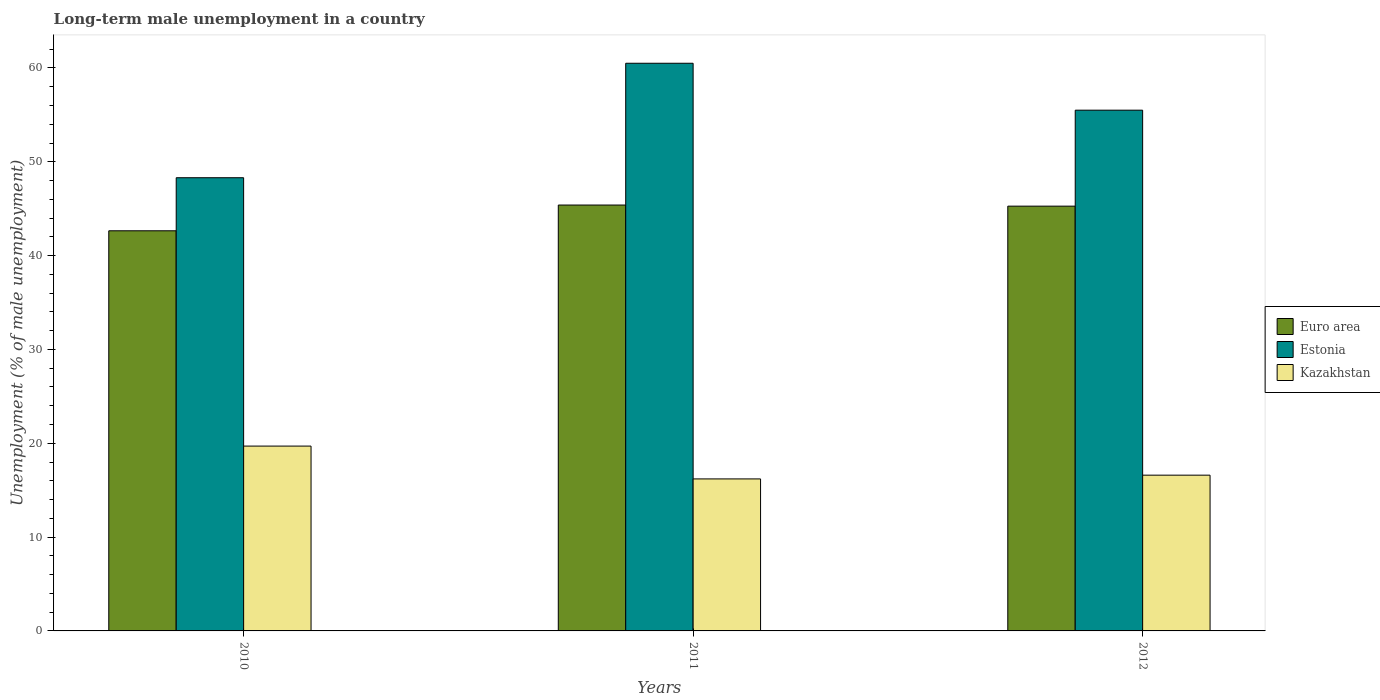How many different coloured bars are there?
Give a very brief answer. 3. Are the number of bars on each tick of the X-axis equal?
Provide a succinct answer. Yes. How many bars are there on the 3rd tick from the left?
Provide a succinct answer. 3. What is the percentage of long-term unemployed male population in Estonia in 2010?
Your response must be concise. 48.3. Across all years, what is the maximum percentage of long-term unemployed male population in Kazakhstan?
Offer a terse response. 19.7. Across all years, what is the minimum percentage of long-term unemployed male population in Euro area?
Your answer should be compact. 42.65. In which year was the percentage of long-term unemployed male population in Kazakhstan maximum?
Your response must be concise. 2010. In which year was the percentage of long-term unemployed male population in Estonia minimum?
Keep it short and to the point. 2010. What is the total percentage of long-term unemployed male population in Kazakhstan in the graph?
Make the answer very short. 52.5. What is the difference between the percentage of long-term unemployed male population in Estonia in 2010 and that in 2011?
Offer a very short reply. -12.2. What is the difference between the percentage of long-term unemployed male population in Estonia in 2010 and the percentage of long-term unemployed male population in Kazakhstan in 2012?
Your answer should be very brief. 31.7. What is the average percentage of long-term unemployed male population in Estonia per year?
Offer a very short reply. 54.77. In the year 2011, what is the difference between the percentage of long-term unemployed male population in Kazakhstan and percentage of long-term unemployed male population in Euro area?
Your answer should be very brief. -29.19. In how many years, is the percentage of long-term unemployed male population in Estonia greater than 16 %?
Give a very brief answer. 3. What is the ratio of the percentage of long-term unemployed male population in Kazakhstan in 2010 to that in 2011?
Ensure brevity in your answer.  1.22. Is the percentage of long-term unemployed male population in Kazakhstan in 2010 less than that in 2011?
Your answer should be very brief. No. What is the difference between the highest and the lowest percentage of long-term unemployed male population in Euro area?
Provide a succinct answer. 2.74. In how many years, is the percentage of long-term unemployed male population in Estonia greater than the average percentage of long-term unemployed male population in Estonia taken over all years?
Keep it short and to the point. 2. What does the 2nd bar from the left in 2010 represents?
Make the answer very short. Estonia. What does the 2nd bar from the right in 2012 represents?
Offer a very short reply. Estonia. How many years are there in the graph?
Provide a short and direct response. 3. What is the difference between two consecutive major ticks on the Y-axis?
Keep it short and to the point. 10. Are the values on the major ticks of Y-axis written in scientific E-notation?
Offer a very short reply. No. How many legend labels are there?
Keep it short and to the point. 3. What is the title of the graph?
Your response must be concise. Long-term male unemployment in a country. Does "Cabo Verde" appear as one of the legend labels in the graph?
Provide a short and direct response. No. What is the label or title of the X-axis?
Provide a succinct answer. Years. What is the label or title of the Y-axis?
Give a very brief answer. Unemployment (% of male unemployment). What is the Unemployment (% of male unemployment) in Euro area in 2010?
Give a very brief answer. 42.65. What is the Unemployment (% of male unemployment) of Estonia in 2010?
Make the answer very short. 48.3. What is the Unemployment (% of male unemployment) of Kazakhstan in 2010?
Keep it short and to the point. 19.7. What is the Unemployment (% of male unemployment) of Euro area in 2011?
Your response must be concise. 45.39. What is the Unemployment (% of male unemployment) of Estonia in 2011?
Provide a short and direct response. 60.5. What is the Unemployment (% of male unemployment) in Kazakhstan in 2011?
Provide a succinct answer. 16.2. What is the Unemployment (% of male unemployment) of Euro area in 2012?
Give a very brief answer. 45.27. What is the Unemployment (% of male unemployment) in Estonia in 2012?
Provide a succinct answer. 55.5. What is the Unemployment (% of male unemployment) of Kazakhstan in 2012?
Ensure brevity in your answer.  16.6. Across all years, what is the maximum Unemployment (% of male unemployment) of Euro area?
Provide a succinct answer. 45.39. Across all years, what is the maximum Unemployment (% of male unemployment) in Estonia?
Provide a short and direct response. 60.5. Across all years, what is the maximum Unemployment (% of male unemployment) in Kazakhstan?
Offer a terse response. 19.7. Across all years, what is the minimum Unemployment (% of male unemployment) in Euro area?
Your answer should be very brief. 42.65. Across all years, what is the minimum Unemployment (% of male unemployment) of Estonia?
Provide a succinct answer. 48.3. Across all years, what is the minimum Unemployment (% of male unemployment) of Kazakhstan?
Your answer should be very brief. 16.2. What is the total Unemployment (% of male unemployment) in Euro area in the graph?
Offer a very short reply. 133.31. What is the total Unemployment (% of male unemployment) of Estonia in the graph?
Offer a very short reply. 164.3. What is the total Unemployment (% of male unemployment) in Kazakhstan in the graph?
Keep it short and to the point. 52.5. What is the difference between the Unemployment (% of male unemployment) of Euro area in 2010 and that in 2011?
Your response must be concise. -2.74. What is the difference between the Unemployment (% of male unemployment) of Kazakhstan in 2010 and that in 2011?
Ensure brevity in your answer.  3.5. What is the difference between the Unemployment (% of male unemployment) in Euro area in 2010 and that in 2012?
Give a very brief answer. -2.63. What is the difference between the Unemployment (% of male unemployment) in Kazakhstan in 2010 and that in 2012?
Give a very brief answer. 3.1. What is the difference between the Unemployment (% of male unemployment) of Euro area in 2011 and that in 2012?
Give a very brief answer. 0.12. What is the difference between the Unemployment (% of male unemployment) of Estonia in 2011 and that in 2012?
Make the answer very short. 5. What is the difference between the Unemployment (% of male unemployment) of Euro area in 2010 and the Unemployment (% of male unemployment) of Estonia in 2011?
Provide a succinct answer. -17.85. What is the difference between the Unemployment (% of male unemployment) in Euro area in 2010 and the Unemployment (% of male unemployment) in Kazakhstan in 2011?
Your response must be concise. 26.45. What is the difference between the Unemployment (% of male unemployment) of Estonia in 2010 and the Unemployment (% of male unemployment) of Kazakhstan in 2011?
Your answer should be compact. 32.1. What is the difference between the Unemployment (% of male unemployment) of Euro area in 2010 and the Unemployment (% of male unemployment) of Estonia in 2012?
Your answer should be very brief. -12.85. What is the difference between the Unemployment (% of male unemployment) of Euro area in 2010 and the Unemployment (% of male unemployment) of Kazakhstan in 2012?
Your response must be concise. 26.05. What is the difference between the Unemployment (% of male unemployment) of Estonia in 2010 and the Unemployment (% of male unemployment) of Kazakhstan in 2012?
Provide a short and direct response. 31.7. What is the difference between the Unemployment (% of male unemployment) in Euro area in 2011 and the Unemployment (% of male unemployment) in Estonia in 2012?
Your answer should be very brief. -10.11. What is the difference between the Unemployment (% of male unemployment) of Euro area in 2011 and the Unemployment (% of male unemployment) of Kazakhstan in 2012?
Offer a very short reply. 28.79. What is the difference between the Unemployment (% of male unemployment) in Estonia in 2011 and the Unemployment (% of male unemployment) in Kazakhstan in 2012?
Ensure brevity in your answer.  43.9. What is the average Unemployment (% of male unemployment) in Euro area per year?
Keep it short and to the point. 44.44. What is the average Unemployment (% of male unemployment) in Estonia per year?
Give a very brief answer. 54.77. In the year 2010, what is the difference between the Unemployment (% of male unemployment) of Euro area and Unemployment (% of male unemployment) of Estonia?
Your answer should be compact. -5.65. In the year 2010, what is the difference between the Unemployment (% of male unemployment) in Euro area and Unemployment (% of male unemployment) in Kazakhstan?
Provide a succinct answer. 22.95. In the year 2010, what is the difference between the Unemployment (% of male unemployment) of Estonia and Unemployment (% of male unemployment) of Kazakhstan?
Provide a succinct answer. 28.6. In the year 2011, what is the difference between the Unemployment (% of male unemployment) of Euro area and Unemployment (% of male unemployment) of Estonia?
Ensure brevity in your answer.  -15.11. In the year 2011, what is the difference between the Unemployment (% of male unemployment) in Euro area and Unemployment (% of male unemployment) in Kazakhstan?
Your response must be concise. 29.19. In the year 2011, what is the difference between the Unemployment (% of male unemployment) of Estonia and Unemployment (% of male unemployment) of Kazakhstan?
Your answer should be very brief. 44.3. In the year 2012, what is the difference between the Unemployment (% of male unemployment) in Euro area and Unemployment (% of male unemployment) in Estonia?
Your answer should be very brief. -10.23. In the year 2012, what is the difference between the Unemployment (% of male unemployment) of Euro area and Unemployment (% of male unemployment) of Kazakhstan?
Give a very brief answer. 28.67. In the year 2012, what is the difference between the Unemployment (% of male unemployment) of Estonia and Unemployment (% of male unemployment) of Kazakhstan?
Ensure brevity in your answer.  38.9. What is the ratio of the Unemployment (% of male unemployment) of Euro area in 2010 to that in 2011?
Give a very brief answer. 0.94. What is the ratio of the Unemployment (% of male unemployment) of Estonia in 2010 to that in 2011?
Your answer should be compact. 0.8. What is the ratio of the Unemployment (% of male unemployment) of Kazakhstan in 2010 to that in 2011?
Your answer should be compact. 1.22. What is the ratio of the Unemployment (% of male unemployment) in Euro area in 2010 to that in 2012?
Offer a very short reply. 0.94. What is the ratio of the Unemployment (% of male unemployment) in Estonia in 2010 to that in 2012?
Your answer should be compact. 0.87. What is the ratio of the Unemployment (% of male unemployment) of Kazakhstan in 2010 to that in 2012?
Provide a succinct answer. 1.19. What is the ratio of the Unemployment (% of male unemployment) in Estonia in 2011 to that in 2012?
Offer a very short reply. 1.09. What is the ratio of the Unemployment (% of male unemployment) of Kazakhstan in 2011 to that in 2012?
Offer a terse response. 0.98. What is the difference between the highest and the second highest Unemployment (% of male unemployment) of Euro area?
Offer a terse response. 0.12. What is the difference between the highest and the lowest Unemployment (% of male unemployment) of Euro area?
Provide a short and direct response. 2.74. What is the difference between the highest and the lowest Unemployment (% of male unemployment) of Estonia?
Offer a very short reply. 12.2. What is the difference between the highest and the lowest Unemployment (% of male unemployment) in Kazakhstan?
Ensure brevity in your answer.  3.5. 